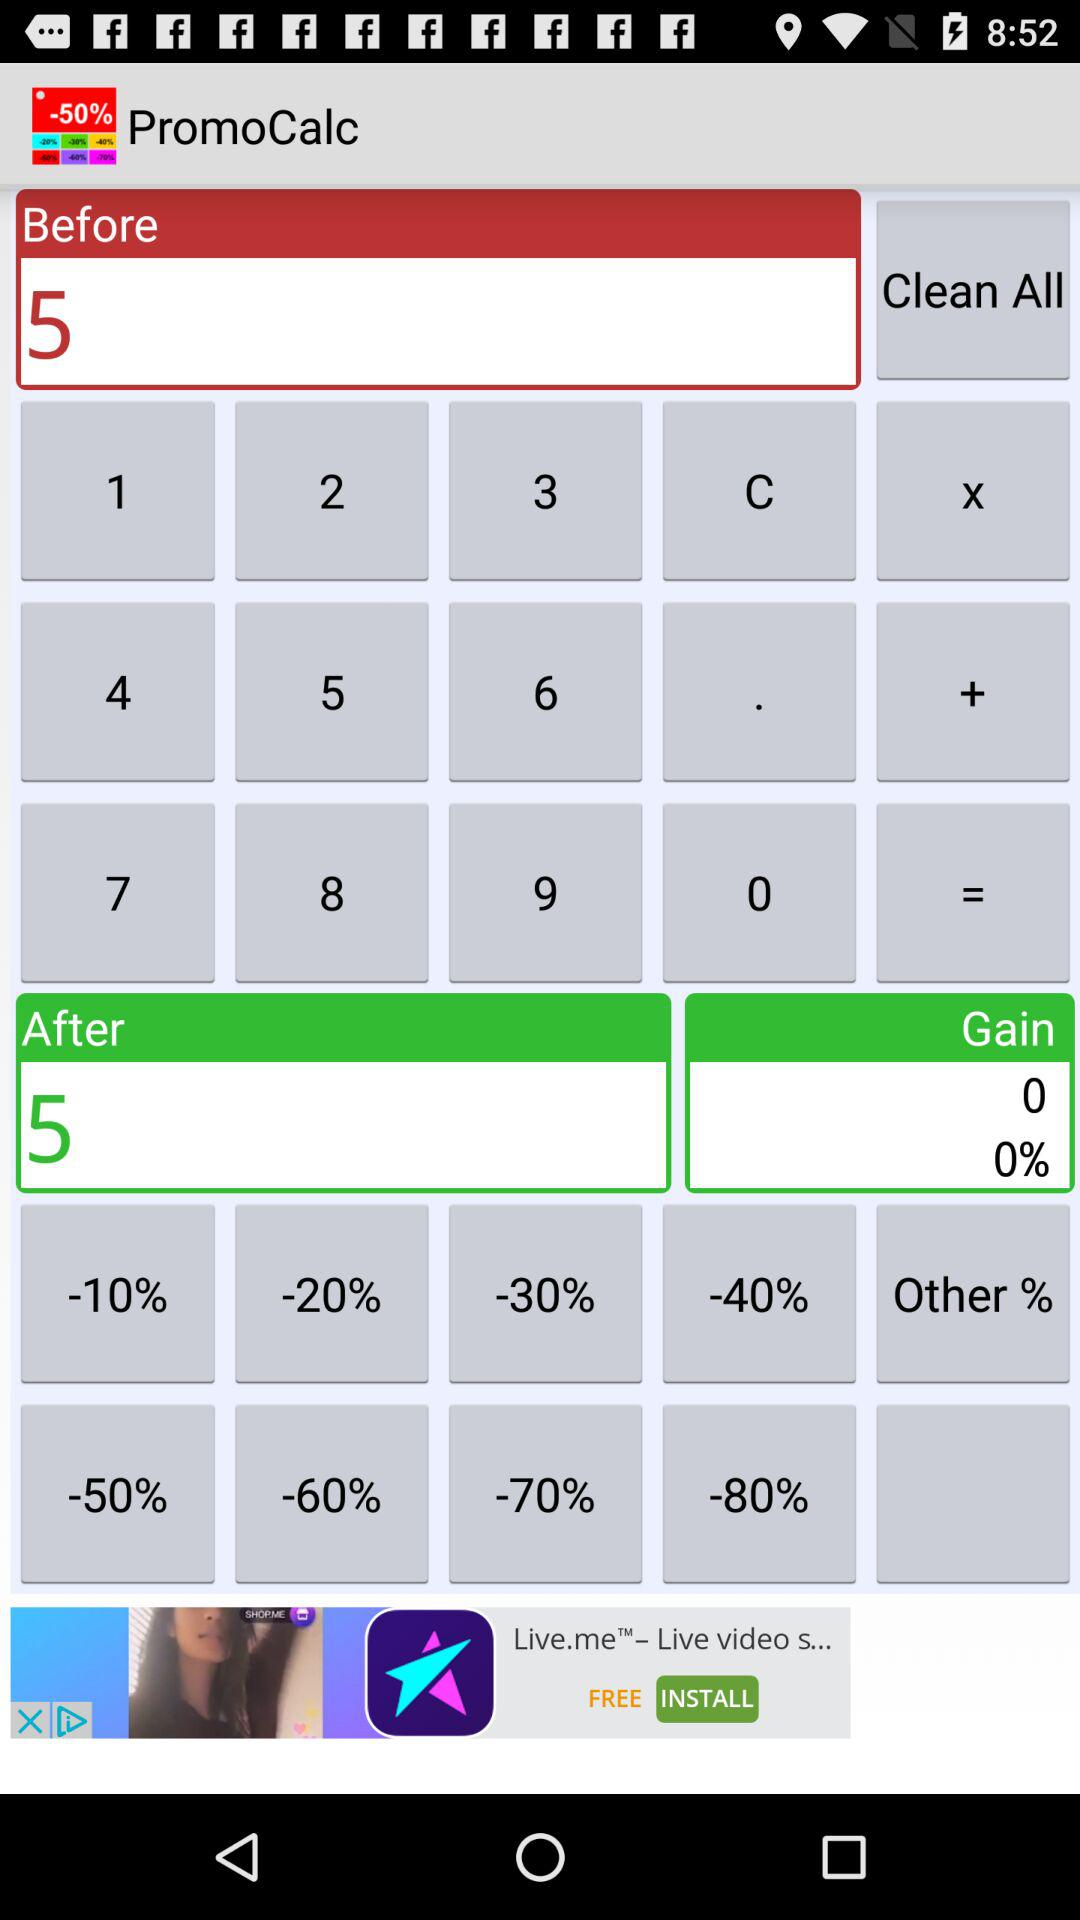What is the number in "After"? The number is 5. 